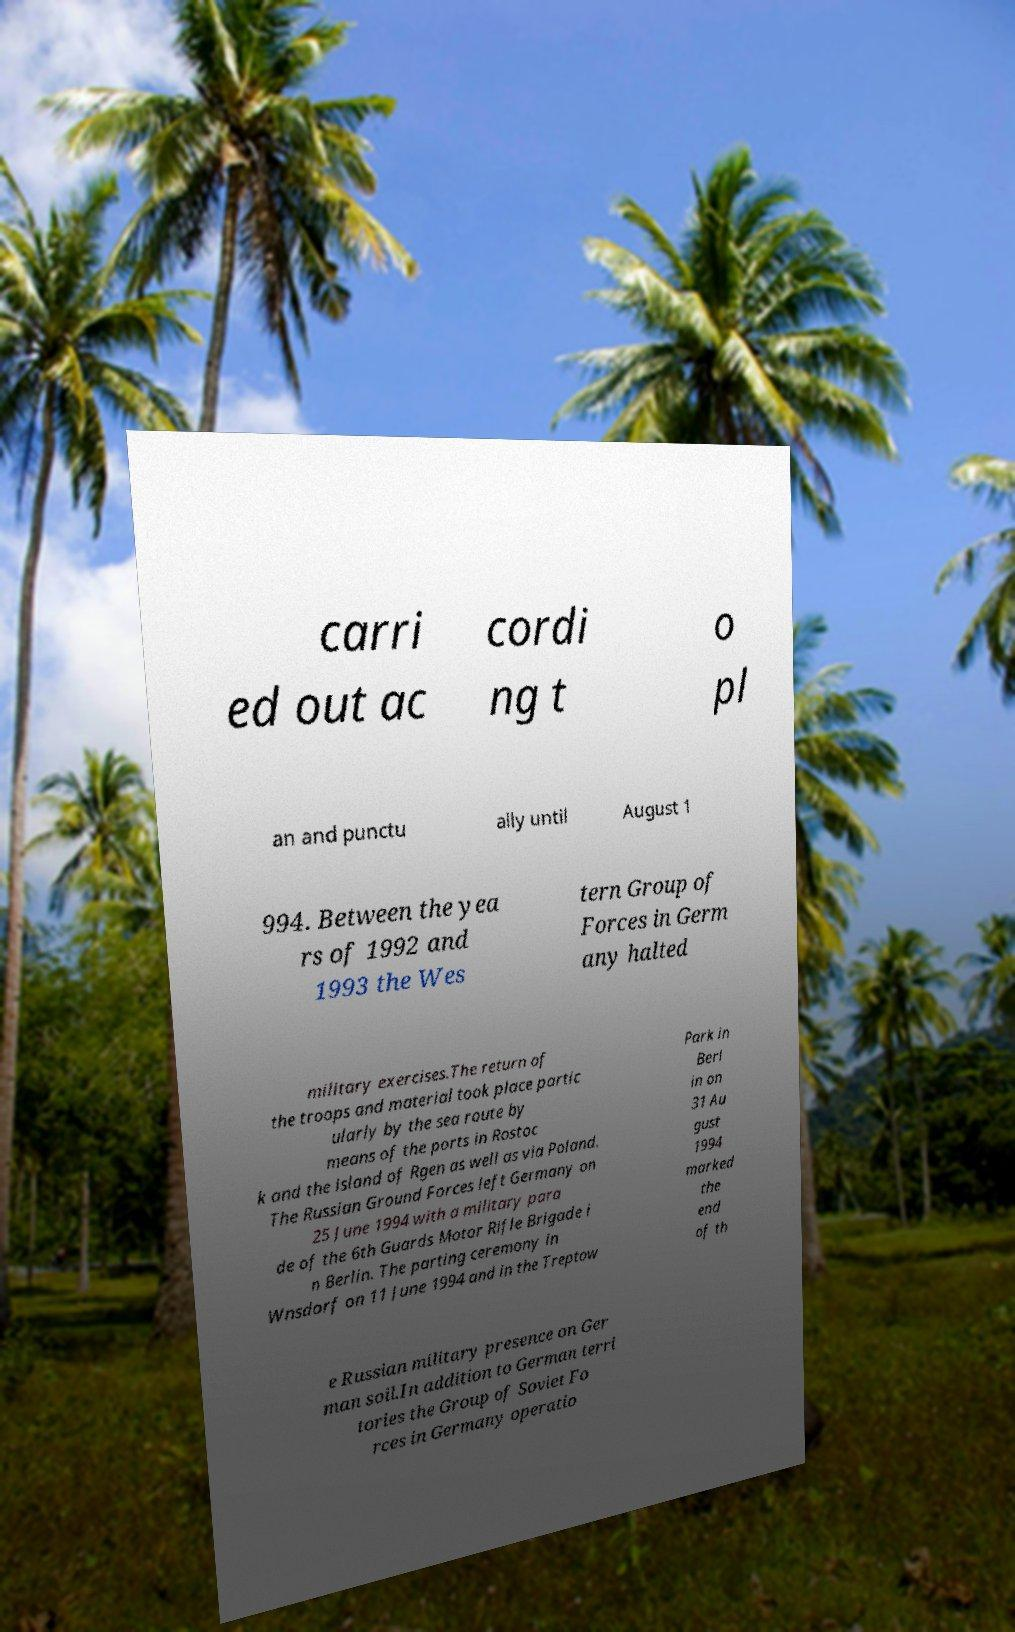Can you read and provide the text displayed in the image?This photo seems to have some interesting text. Can you extract and type it out for me? carri ed out ac cordi ng t o pl an and punctu ally until August 1 994. Between the yea rs of 1992 and 1993 the Wes tern Group of Forces in Germ any halted military exercises.The return of the troops and material took place partic ularly by the sea route by means of the ports in Rostoc k and the island of Rgen as well as via Poland. The Russian Ground Forces left Germany on 25 June 1994 with a military para de of the 6th Guards Motor Rifle Brigade i n Berlin. The parting ceremony in Wnsdorf on 11 June 1994 and in the Treptow Park in Berl in on 31 Au gust 1994 marked the end of th e Russian military presence on Ger man soil.In addition to German terri tories the Group of Soviet Fo rces in Germany operatio 